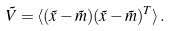<formula> <loc_0><loc_0><loc_500><loc_500>\tilde { V } = \langle ( \tilde { x } - \tilde { m } ) ( \tilde { x } - \tilde { m } ) ^ { T } \rangle \, .</formula> 